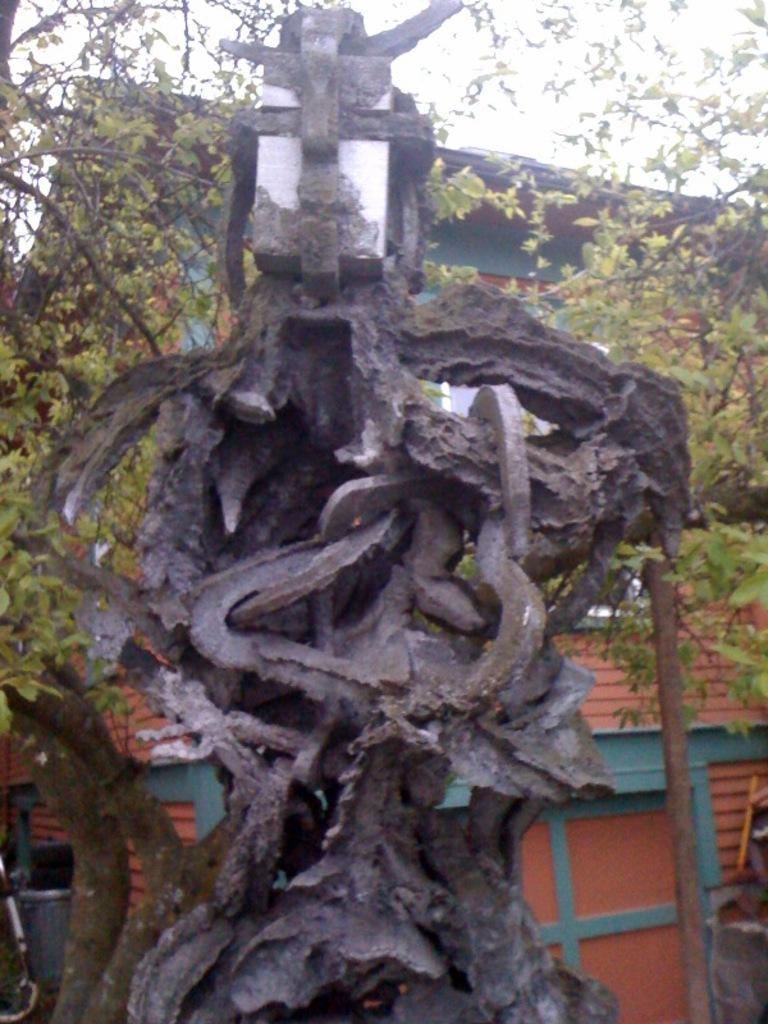Could you give a brief overview of what you see in this image? This is a house and we can see a tree. i think even this is also a tree. 